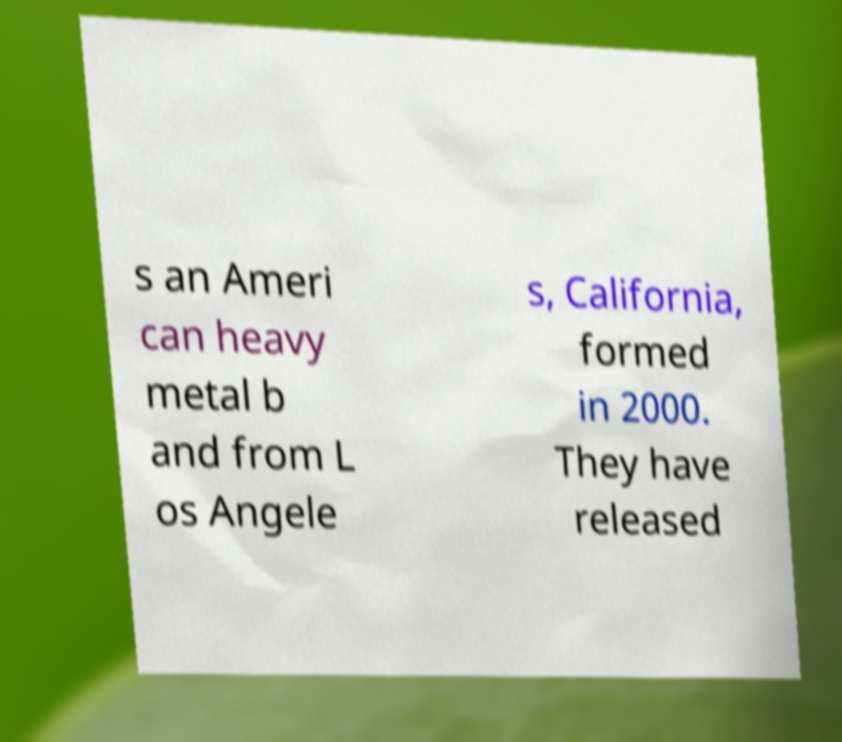I need the written content from this picture converted into text. Can you do that? s an Ameri can heavy metal b and from L os Angele s, California, formed in 2000. They have released 